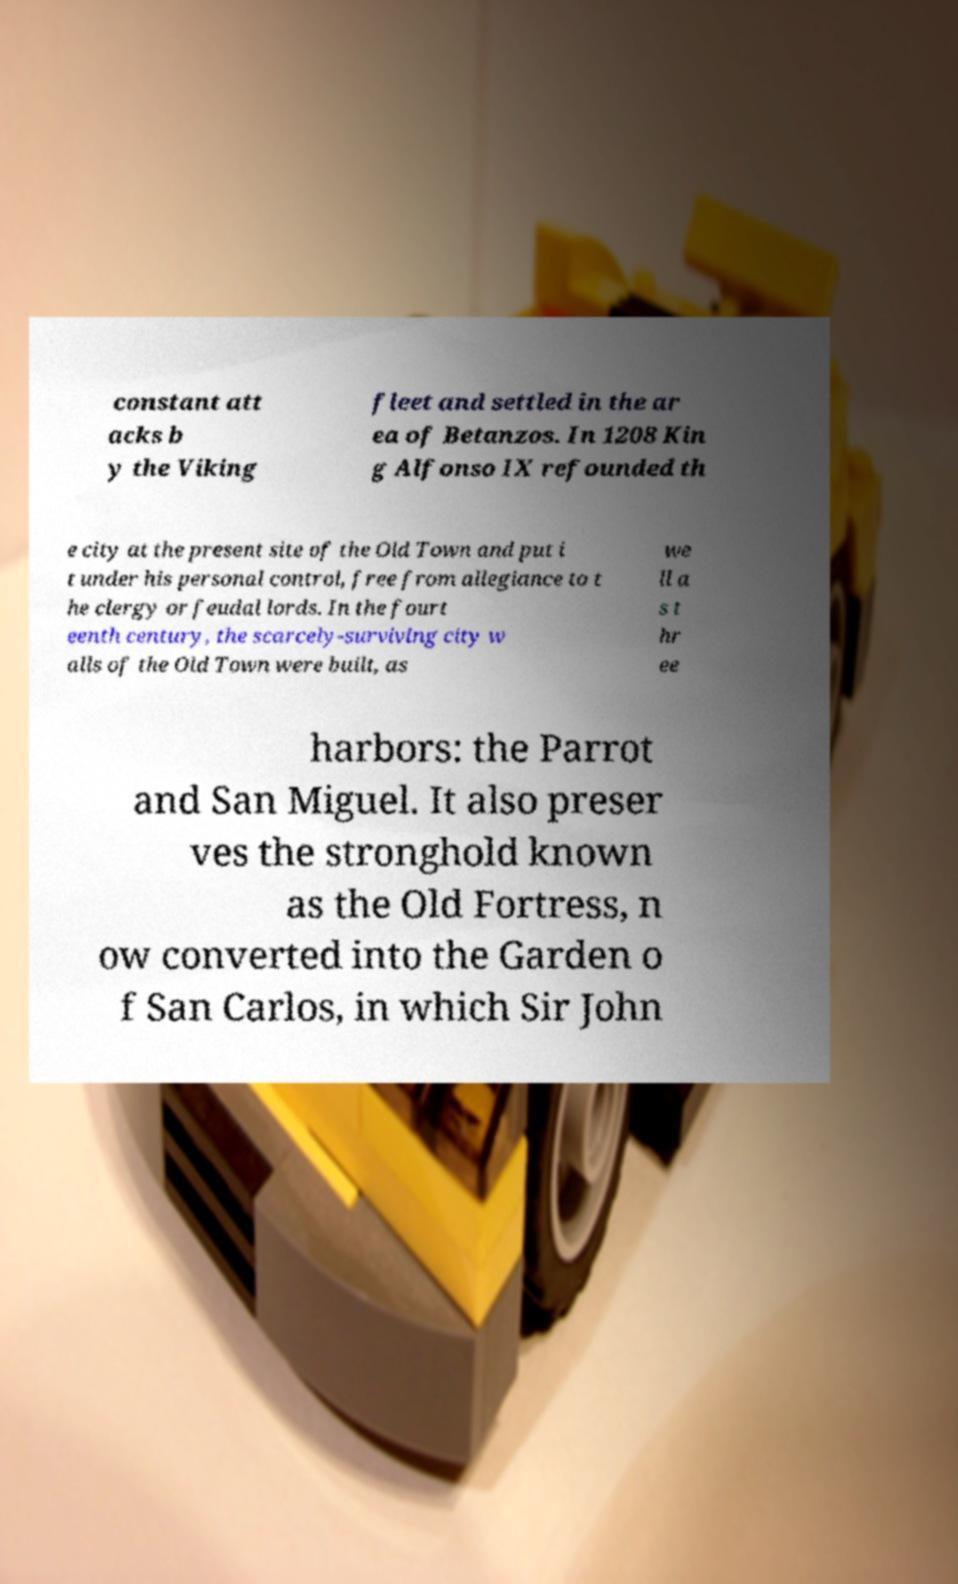Could you assist in decoding the text presented in this image and type it out clearly? constant att acks b y the Viking fleet and settled in the ar ea of Betanzos. In 1208 Kin g Alfonso IX refounded th e city at the present site of the Old Town and put i t under his personal control, free from allegiance to t he clergy or feudal lords. In the fourt eenth century, the scarcely-surviving city w alls of the Old Town were built, as we ll a s t hr ee harbors: the Parrot and San Miguel. It also preser ves the stronghold known as the Old Fortress, n ow converted into the Garden o f San Carlos, in which Sir John 